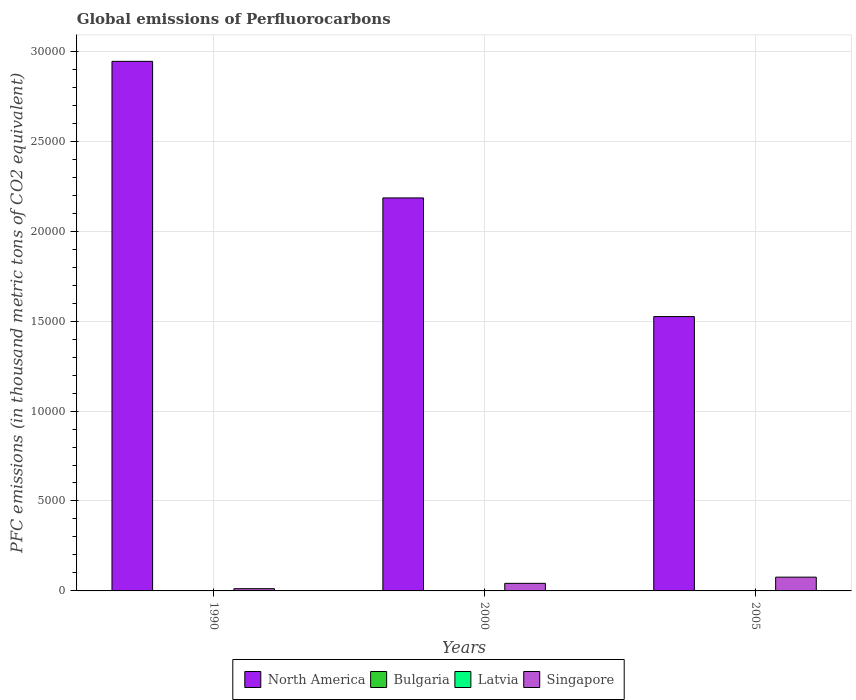How many different coloured bars are there?
Offer a terse response. 4. Are the number of bars on each tick of the X-axis equal?
Offer a terse response. Yes. What is the label of the 3rd group of bars from the left?
Give a very brief answer. 2005. In how many cases, is the number of bars for a given year not equal to the number of legend labels?
Provide a short and direct response. 0. What is the global emissions of Perfluorocarbons in North America in 2005?
Offer a terse response. 1.53e+04. Across all years, what is the maximum global emissions of Perfluorocarbons in Singapore?
Ensure brevity in your answer.  765.5. Across all years, what is the minimum global emissions of Perfluorocarbons in Latvia?
Provide a short and direct response. 0.7. In which year was the global emissions of Perfluorocarbons in Singapore minimum?
Offer a terse response. 1990. What is the total global emissions of Perfluorocarbons in Bulgaria in the graph?
Give a very brief answer. 39.8. What is the difference between the global emissions of Perfluorocarbons in North America in 2005 and the global emissions of Perfluorocarbons in Singapore in 1990?
Make the answer very short. 1.51e+04. What is the average global emissions of Perfluorocarbons in Singapore per year?
Provide a short and direct response. 436.87. In the year 1990, what is the difference between the global emissions of Perfluorocarbons in Latvia and global emissions of Perfluorocarbons in Singapore?
Your response must be concise. -123.5. In how many years, is the global emissions of Perfluorocarbons in Singapore greater than 17000 thousand metric tons?
Provide a succinct answer. 0. What is the ratio of the global emissions of Perfluorocarbons in North America in 2000 to that in 2005?
Offer a terse response. 1.43. Is the global emissions of Perfluorocarbons in North America in 1990 less than that in 2005?
Keep it short and to the point. No. Is the difference between the global emissions of Perfluorocarbons in Latvia in 1990 and 2000 greater than the difference between the global emissions of Perfluorocarbons in Singapore in 1990 and 2000?
Your response must be concise. Yes. What is the difference between the highest and the second highest global emissions of Perfluorocarbons in Latvia?
Your answer should be very brief. 0.2. What is the difference between the highest and the lowest global emissions of Perfluorocarbons in Latvia?
Your response must be concise. 5. In how many years, is the global emissions of Perfluorocarbons in Latvia greater than the average global emissions of Perfluorocarbons in Latvia taken over all years?
Offer a terse response. 2. Is the sum of the global emissions of Perfluorocarbons in Singapore in 1990 and 2005 greater than the maximum global emissions of Perfluorocarbons in Bulgaria across all years?
Offer a very short reply. Yes. What does the 1st bar from the left in 1990 represents?
Your answer should be compact. North America. What does the 2nd bar from the right in 2005 represents?
Give a very brief answer. Latvia. How many bars are there?
Keep it short and to the point. 12. Are the values on the major ticks of Y-axis written in scientific E-notation?
Provide a short and direct response. No. Does the graph contain any zero values?
Your answer should be very brief. No. Where does the legend appear in the graph?
Offer a terse response. Bottom center. How are the legend labels stacked?
Offer a terse response. Horizontal. What is the title of the graph?
Make the answer very short. Global emissions of Perfluorocarbons. What is the label or title of the Y-axis?
Offer a very short reply. PFC emissions (in thousand metric tons of CO2 equivalent). What is the PFC emissions (in thousand metric tons of CO2 equivalent) of North America in 1990?
Offer a very short reply. 2.94e+04. What is the PFC emissions (in thousand metric tons of CO2 equivalent) in Singapore in 1990?
Your answer should be very brief. 124.2. What is the PFC emissions (in thousand metric tons of CO2 equivalent) in North America in 2000?
Make the answer very short. 2.18e+04. What is the PFC emissions (in thousand metric tons of CO2 equivalent) of Bulgaria in 2000?
Keep it short and to the point. 19.1. What is the PFC emissions (in thousand metric tons of CO2 equivalent) of Singapore in 2000?
Provide a short and direct response. 420.9. What is the PFC emissions (in thousand metric tons of CO2 equivalent) of North America in 2005?
Your answer should be very brief. 1.53e+04. What is the PFC emissions (in thousand metric tons of CO2 equivalent) in Bulgaria in 2005?
Provide a short and direct response. 18.5. What is the PFC emissions (in thousand metric tons of CO2 equivalent) of Latvia in 2005?
Your response must be concise. 5.5. What is the PFC emissions (in thousand metric tons of CO2 equivalent) in Singapore in 2005?
Your answer should be compact. 765.5. Across all years, what is the maximum PFC emissions (in thousand metric tons of CO2 equivalent) of North America?
Offer a very short reply. 2.94e+04. Across all years, what is the maximum PFC emissions (in thousand metric tons of CO2 equivalent) of Singapore?
Offer a terse response. 765.5. Across all years, what is the minimum PFC emissions (in thousand metric tons of CO2 equivalent) of North America?
Keep it short and to the point. 1.53e+04. Across all years, what is the minimum PFC emissions (in thousand metric tons of CO2 equivalent) in Bulgaria?
Give a very brief answer. 2.2. Across all years, what is the minimum PFC emissions (in thousand metric tons of CO2 equivalent) in Latvia?
Offer a very short reply. 0.7. Across all years, what is the minimum PFC emissions (in thousand metric tons of CO2 equivalent) in Singapore?
Your answer should be very brief. 124.2. What is the total PFC emissions (in thousand metric tons of CO2 equivalent) of North America in the graph?
Your answer should be compact. 6.65e+04. What is the total PFC emissions (in thousand metric tons of CO2 equivalent) of Bulgaria in the graph?
Provide a short and direct response. 39.8. What is the total PFC emissions (in thousand metric tons of CO2 equivalent) in Singapore in the graph?
Your answer should be compact. 1310.6. What is the difference between the PFC emissions (in thousand metric tons of CO2 equivalent) of North America in 1990 and that in 2000?
Ensure brevity in your answer.  7592.7. What is the difference between the PFC emissions (in thousand metric tons of CO2 equivalent) of Bulgaria in 1990 and that in 2000?
Provide a succinct answer. -16.9. What is the difference between the PFC emissions (in thousand metric tons of CO2 equivalent) of Singapore in 1990 and that in 2000?
Give a very brief answer. -296.7. What is the difference between the PFC emissions (in thousand metric tons of CO2 equivalent) of North America in 1990 and that in 2005?
Keep it short and to the point. 1.42e+04. What is the difference between the PFC emissions (in thousand metric tons of CO2 equivalent) in Bulgaria in 1990 and that in 2005?
Provide a short and direct response. -16.3. What is the difference between the PFC emissions (in thousand metric tons of CO2 equivalent) in Latvia in 1990 and that in 2005?
Your answer should be very brief. -4.8. What is the difference between the PFC emissions (in thousand metric tons of CO2 equivalent) of Singapore in 1990 and that in 2005?
Keep it short and to the point. -641.3. What is the difference between the PFC emissions (in thousand metric tons of CO2 equivalent) in North America in 2000 and that in 2005?
Your response must be concise. 6595.81. What is the difference between the PFC emissions (in thousand metric tons of CO2 equivalent) of Singapore in 2000 and that in 2005?
Your answer should be very brief. -344.6. What is the difference between the PFC emissions (in thousand metric tons of CO2 equivalent) of North America in 1990 and the PFC emissions (in thousand metric tons of CO2 equivalent) of Bulgaria in 2000?
Offer a terse response. 2.94e+04. What is the difference between the PFC emissions (in thousand metric tons of CO2 equivalent) in North America in 1990 and the PFC emissions (in thousand metric tons of CO2 equivalent) in Latvia in 2000?
Offer a very short reply. 2.94e+04. What is the difference between the PFC emissions (in thousand metric tons of CO2 equivalent) of North America in 1990 and the PFC emissions (in thousand metric tons of CO2 equivalent) of Singapore in 2000?
Your answer should be compact. 2.90e+04. What is the difference between the PFC emissions (in thousand metric tons of CO2 equivalent) in Bulgaria in 1990 and the PFC emissions (in thousand metric tons of CO2 equivalent) in Latvia in 2000?
Give a very brief answer. -3.5. What is the difference between the PFC emissions (in thousand metric tons of CO2 equivalent) in Bulgaria in 1990 and the PFC emissions (in thousand metric tons of CO2 equivalent) in Singapore in 2000?
Your response must be concise. -418.7. What is the difference between the PFC emissions (in thousand metric tons of CO2 equivalent) of Latvia in 1990 and the PFC emissions (in thousand metric tons of CO2 equivalent) of Singapore in 2000?
Your answer should be very brief. -420.2. What is the difference between the PFC emissions (in thousand metric tons of CO2 equivalent) in North America in 1990 and the PFC emissions (in thousand metric tons of CO2 equivalent) in Bulgaria in 2005?
Provide a short and direct response. 2.94e+04. What is the difference between the PFC emissions (in thousand metric tons of CO2 equivalent) in North America in 1990 and the PFC emissions (in thousand metric tons of CO2 equivalent) in Latvia in 2005?
Your answer should be very brief. 2.94e+04. What is the difference between the PFC emissions (in thousand metric tons of CO2 equivalent) of North America in 1990 and the PFC emissions (in thousand metric tons of CO2 equivalent) of Singapore in 2005?
Offer a very short reply. 2.87e+04. What is the difference between the PFC emissions (in thousand metric tons of CO2 equivalent) of Bulgaria in 1990 and the PFC emissions (in thousand metric tons of CO2 equivalent) of Singapore in 2005?
Give a very brief answer. -763.3. What is the difference between the PFC emissions (in thousand metric tons of CO2 equivalent) in Latvia in 1990 and the PFC emissions (in thousand metric tons of CO2 equivalent) in Singapore in 2005?
Offer a terse response. -764.8. What is the difference between the PFC emissions (in thousand metric tons of CO2 equivalent) of North America in 2000 and the PFC emissions (in thousand metric tons of CO2 equivalent) of Bulgaria in 2005?
Provide a short and direct response. 2.18e+04. What is the difference between the PFC emissions (in thousand metric tons of CO2 equivalent) of North America in 2000 and the PFC emissions (in thousand metric tons of CO2 equivalent) of Latvia in 2005?
Your answer should be compact. 2.18e+04. What is the difference between the PFC emissions (in thousand metric tons of CO2 equivalent) in North America in 2000 and the PFC emissions (in thousand metric tons of CO2 equivalent) in Singapore in 2005?
Your answer should be very brief. 2.11e+04. What is the difference between the PFC emissions (in thousand metric tons of CO2 equivalent) of Bulgaria in 2000 and the PFC emissions (in thousand metric tons of CO2 equivalent) of Singapore in 2005?
Provide a succinct answer. -746.4. What is the difference between the PFC emissions (in thousand metric tons of CO2 equivalent) of Latvia in 2000 and the PFC emissions (in thousand metric tons of CO2 equivalent) of Singapore in 2005?
Your response must be concise. -759.8. What is the average PFC emissions (in thousand metric tons of CO2 equivalent) in North America per year?
Your answer should be compact. 2.22e+04. What is the average PFC emissions (in thousand metric tons of CO2 equivalent) of Bulgaria per year?
Your answer should be compact. 13.27. What is the average PFC emissions (in thousand metric tons of CO2 equivalent) of Latvia per year?
Provide a short and direct response. 3.97. What is the average PFC emissions (in thousand metric tons of CO2 equivalent) of Singapore per year?
Your answer should be compact. 436.87. In the year 1990, what is the difference between the PFC emissions (in thousand metric tons of CO2 equivalent) in North America and PFC emissions (in thousand metric tons of CO2 equivalent) in Bulgaria?
Offer a very short reply. 2.94e+04. In the year 1990, what is the difference between the PFC emissions (in thousand metric tons of CO2 equivalent) of North America and PFC emissions (in thousand metric tons of CO2 equivalent) of Latvia?
Make the answer very short. 2.94e+04. In the year 1990, what is the difference between the PFC emissions (in thousand metric tons of CO2 equivalent) in North America and PFC emissions (in thousand metric tons of CO2 equivalent) in Singapore?
Your response must be concise. 2.93e+04. In the year 1990, what is the difference between the PFC emissions (in thousand metric tons of CO2 equivalent) in Bulgaria and PFC emissions (in thousand metric tons of CO2 equivalent) in Latvia?
Provide a short and direct response. 1.5. In the year 1990, what is the difference between the PFC emissions (in thousand metric tons of CO2 equivalent) in Bulgaria and PFC emissions (in thousand metric tons of CO2 equivalent) in Singapore?
Offer a very short reply. -122. In the year 1990, what is the difference between the PFC emissions (in thousand metric tons of CO2 equivalent) of Latvia and PFC emissions (in thousand metric tons of CO2 equivalent) of Singapore?
Your answer should be compact. -123.5. In the year 2000, what is the difference between the PFC emissions (in thousand metric tons of CO2 equivalent) of North America and PFC emissions (in thousand metric tons of CO2 equivalent) of Bulgaria?
Provide a short and direct response. 2.18e+04. In the year 2000, what is the difference between the PFC emissions (in thousand metric tons of CO2 equivalent) in North America and PFC emissions (in thousand metric tons of CO2 equivalent) in Latvia?
Provide a succinct answer. 2.18e+04. In the year 2000, what is the difference between the PFC emissions (in thousand metric tons of CO2 equivalent) in North America and PFC emissions (in thousand metric tons of CO2 equivalent) in Singapore?
Provide a short and direct response. 2.14e+04. In the year 2000, what is the difference between the PFC emissions (in thousand metric tons of CO2 equivalent) in Bulgaria and PFC emissions (in thousand metric tons of CO2 equivalent) in Singapore?
Your response must be concise. -401.8. In the year 2000, what is the difference between the PFC emissions (in thousand metric tons of CO2 equivalent) of Latvia and PFC emissions (in thousand metric tons of CO2 equivalent) of Singapore?
Make the answer very short. -415.2. In the year 2005, what is the difference between the PFC emissions (in thousand metric tons of CO2 equivalent) in North America and PFC emissions (in thousand metric tons of CO2 equivalent) in Bulgaria?
Keep it short and to the point. 1.52e+04. In the year 2005, what is the difference between the PFC emissions (in thousand metric tons of CO2 equivalent) in North America and PFC emissions (in thousand metric tons of CO2 equivalent) in Latvia?
Offer a terse response. 1.52e+04. In the year 2005, what is the difference between the PFC emissions (in thousand metric tons of CO2 equivalent) in North America and PFC emissions (in thousand metric tons of CO2 equivalent) in Singapore?
Provide a short and direct response. 1.45e+04. In the year 2005, what is the difference between the PFC emissions (in thousand metric tons of CO2 equivalent) in Bulgaria and PFC emissions (in thousand metric tons of CO2 equivalent) in Singapore?
Give a very brief answer. -747. In the year 2005, what is the difference between the PFC emissions (in thousand metric tons of CO2 equivalent) of Latvia and PFC emissions (in thousand metric tons of CO2 equivalent) of Singapore?
Your answer should be compact. -760. What is the ratio of the PFC emissions (in thousand metric tons of CO2 equivalent) in North America in 1990 to that in 2000?
Make the answer very short. 1.35. What is the ratio of the PFC emissions (in thousand metric tons of CO2 equivalent) of Bulgaria in 1990 to that in 2000?
Your answer should be very brief. 0.12. What is the ratio of the PFC emissions (in thousand metric tons of CO2 equivalent) in Latvia in 1990 to that in 2000?
Your answer should be compact. 0.12. What is the ratio of the PFC emissions (in thousand metric tons of CO2 equivalent) in Singapore in 1990 to that in 2000?
Make the answer very short. 0.3. What is the ratio of the PFC emissions (in thousand metric tons of CO2 equivalent) in North America in 1990 to that in 2005?
Provide a succinct answer. 1.93. What is the ratio of the PFC emissions (in thousand metric tons of CO2 equivalent) in Bulgaria in 1990 to that in 2005?
Give a very brief answer. 0.12. What is the ratio of the PFC emissions (in thousand metric tons of CO2 equivalent) of Latvia in 1990 to that in 2005?
Your answer should be very brief. 0.13. What is the ratio of the PFC emissions (in thousand metric tons of CO2 equivalent) of Singapore in 1990 to that in 2005?
Your answer should be very brief. 0.16. What is the ratio of the PFC emissions (in thousand metric tons of CO2 equivalent) of North America in 2000 to that in 2005?
Your response must be concise. 1.43. What is the ratio of the PFC emissions (in thousand metric tons of CO2 equivalent) in Bulgaria in 2000 to that in 2005?
Make the answer very short. 1.03. What is the ratio of the PFC emissions (in thousand metric tons of CO2 equivalent) in Latvia in 2000 to that in 2005?
Your answer should be very brief. 1.04. What is the ratio of the PFC emissions (in thousand metric tons of CO2 equivalent) of Singapore in 2000 to that in 2005?
Your response must be concise. 0.55. What is the difference between the highest and the second highest PFC emissions (in thousand metric tons of CO2 equivalent) of North America?
Give a very brief answer. 7592.7. What is the difference between the highest and the second highest PFC emissions (in thousand metric tons of CO2 equivalent) of Bulgaria?
Your response must be concise. 0.6. What is the difference between the highest and the second highest PFC emissions (in thousand metric tons of CO2 equivalent) of Singapore?
Your answer should be compact. 344.6. What is the difference between the highest and the lowest PFC emissions (in thousand metric tons of CO2 equivalent) of North America?
Provide a short and direct response. 1.42e+04. What is the difference between the highest and the lowest PFC emissions (in thousand metric tons of CO2 equivalent) in Latvia?
Offer a very short reply. 5. What is the difference between the highest and the lowest PFC emissions (in thousand metric tons of CO2 equivalent) of Singapore?
Provide a succinct answer. 641.3. 